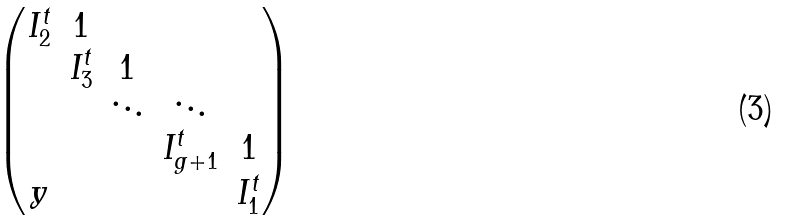Convert formula to latex. <formula><loc_0><loc_0><loc_500><loc_500>\begin{pmatrix} I _ { 2 } ^ { t } & 1 & & & \\ & I _ { 3 } ^ { t } & 1 & & \\ & & \ddots & \ddots & \\ & & & I _ { g + 1 } ^ { t } & 1 \\ y & & & & I _ { 1 } ^ { t } \\ \end{pmatrix}</formula> 